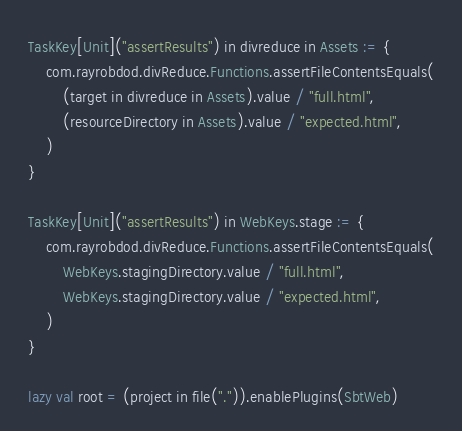Convert code to text. <code><loc_0><loc_0><loc_500><loc_500><_Scala_>TaskKey[Unit]("assertResults") in divreduce in Assets := {
	com.rayrobdod.divReduce.Functions.assertFileContentsEquals(
		(target in divreduce in Assets).value / "full.html",
		(resourceDirectory in Assets).value / "expected.html",
	)
}

TaskKey[Unit]("assertResults") in WebKeys.stage := {
	com.rayrobdod.divReduce.Functions.assertFileContentsEquals(
		WebKeys.stagingDirectory.value / "full.html",
		WebKeys.stagingDirectory.value / "expected.html",
	)
}

lazy val root = (project in file(".")).enablePlugins(SbtWeb)</code> 